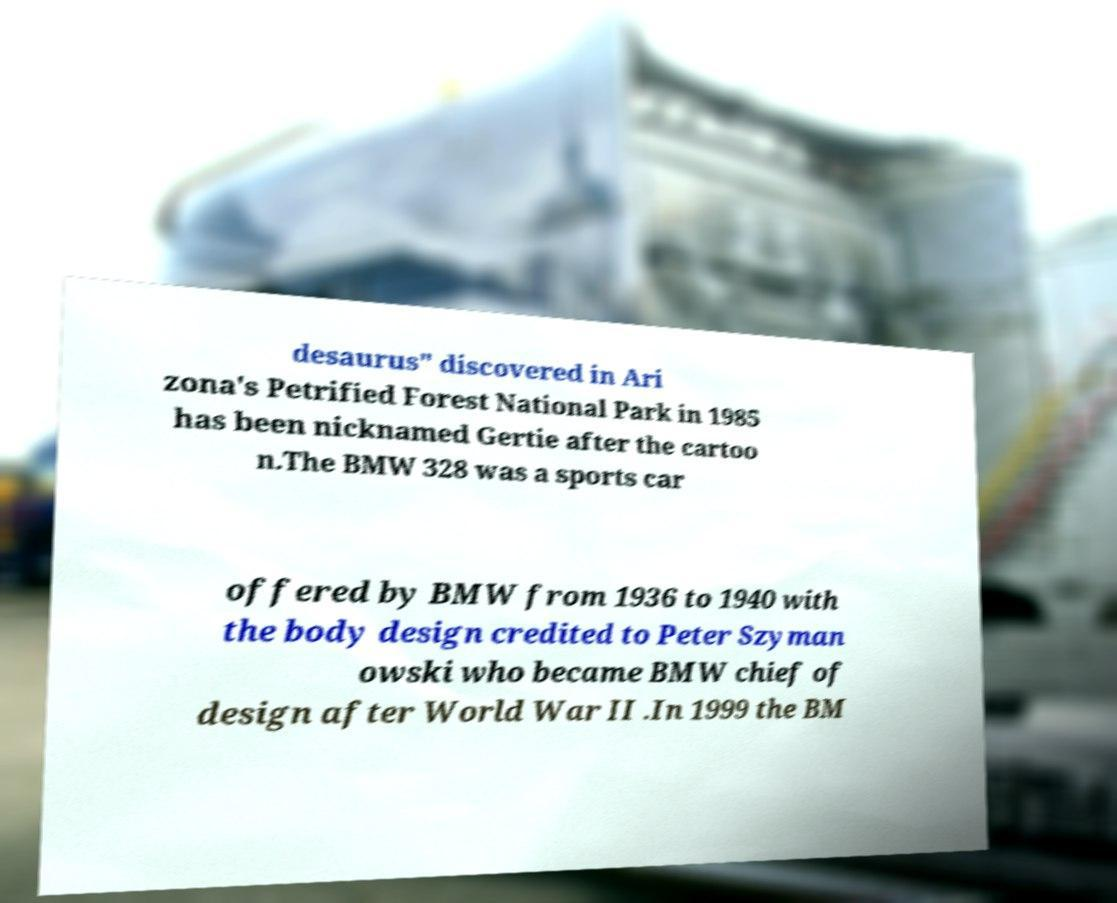Can you read and provide the text displayed in the image?This photo seems to have some interesting text. Can you extract and type it out for me? desaurus" discovered in Ari zona's Petrified Forest National Park in 1985 has been nicknamed Gertie after the cartoo n.The BMW 328 was a sports car offered by BMW from 1936 to 1940 with the body design credited to Peter Szyman owski who became BMW chief of design after World War II .In 1999 the BM 